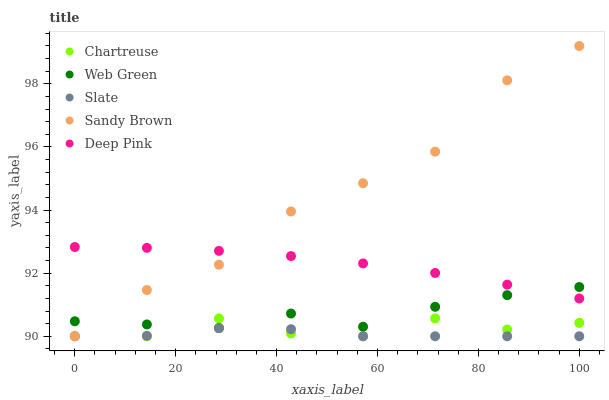Does Slate have the minimum area under the curve?
Answer yes or no. Yes. Does Sandy Brown have the maximum area under the curve?
Answer yes or no. Yes. Does Deep Pink have the minimum area under the curve?
Answer yes or no. No. Does Deep Pink have the maximum area under the curve?
Answer yes or no. No. Is Deep Pink the smoothest?
Answer yes or no. Yes. Is Sandy Brown the roughest?
Answer yes or no. Yes. Is Sandy Brown the smoothest?
Answer yes or no. No. Is Deep Pink the roughest?
Answer yes or no. No. Does Chartreuse have the lowest value?
Answer yes or no. Yes. Does Deep Pink have the lowest value?
Answer yes or no. No. Does Sandy Brown have the highest value?
Answer yes or no. Yes. Does Deep Pink have the highest value?
Answer yes or no. No. Is Slate less than Deep Pink?
Answer yes or no. Yes. Is Web Green greater than Slate?
Answer yes or no. Yes. Does Slate intersect Sandy Brown?
Answer yes or no. Yes. Is Slate less than Sandy Brown?
Answer yes or no. No. Is Slate greater than Sandy Brown?
Answer yes or no. No. Does Slate intersect Deep Pink?
Answer yes or no. No. 